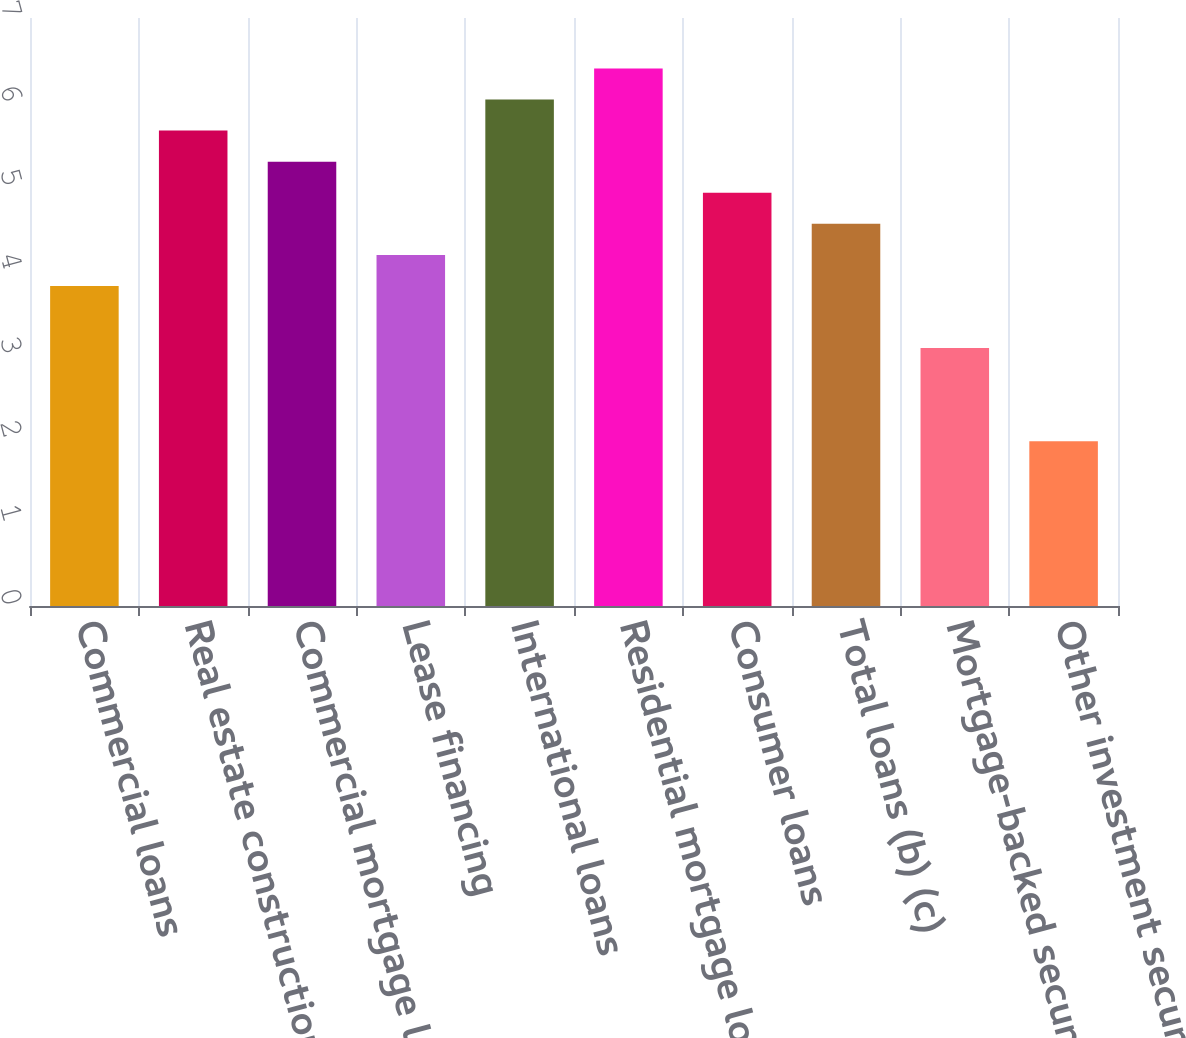Convert chart to OTSL. <chart><loc_0><loc_0><loc_500><loc_500><bar_chart><fcel>Commercial loans<fcel>Real estate construction loans<fcel>Commercial mortgage loans<fcel>Lease financing<fcel>International loans<fcel>Residential mortgage loans<fcel>Consumer loans<fcel>Total loans (b) (c)<fcel>Mortgage-backed securities<fcel>Other investment securities<nl><fcel>3.81<fcel>5.66<fcel>5.29<fcel>4.18<fcel>6.03<fcel>6.4<fcel>4.92<fcel>4.55<fcel>3.07<fcel>1.96<nl></chart> 